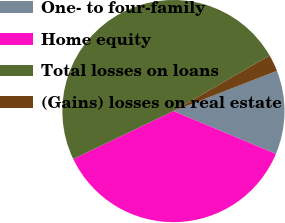<chart> <loc_0><loc_0><loc_500><loc_500><pie_chart><fcel>One- to four-family<fcel>Home equity<fcel>Total losses on loans<fcel>(Gains) losses on real estate<nl><fcel>12.2%<fcel>36.59%<fcel>48.78%<fcel>2.44%<nl></chart> 